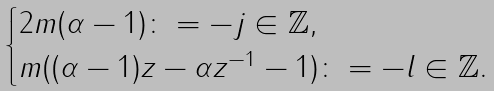<formula> <loc_0><loc_0><loc_500><loc_500>\begin{cases} 2 m ( \alpha - 1 ) \colon = - j \in { \mathbb { Z } } , & \\ m ( ( \alpha - 1 ) z - \alpha z ^ { - 1 } - 1 ) \colon = - l \in { \mathbb { Z } } . & \end{cases}</formula> 